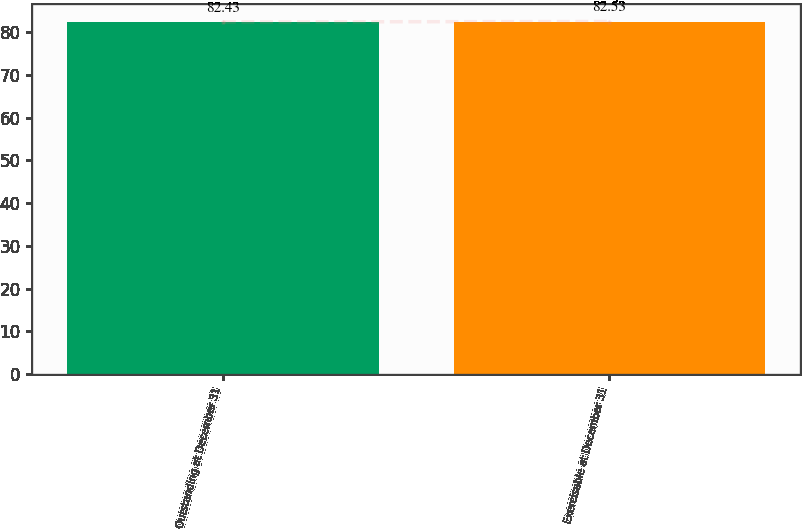<chart> <loc_0><loc_0><loc_500><loc_500><bar_chart><fcel>Outstanding at December 31<fcel>Exercisable at December 31<nl><fcel>82.43<fcel>82.53<nl></chart> 